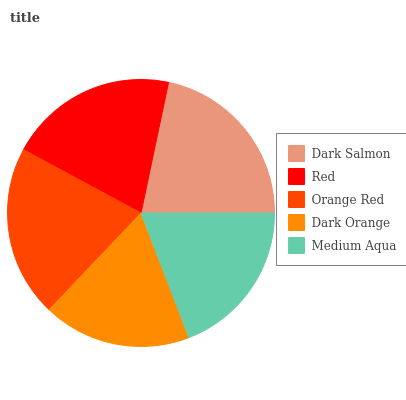Is Dark Orange the minimum?
Answer yes or no. Yes. Is Dark Salmon the maximum?
Answer yes or no. Yes. Is Red the minimum?
Answer yes or no. No. Is Red the maximum?
Answer yes or no. No. Is Dark Salmon greater than Red?
Answer yes or no. Yes. Is Red less than Dark Salmon?
Answer yes or no. Yes. Is Red greater than Dark Salmon?
Answer yes or no. No. Is Dark Salmon less than Red?
Answer yes or no. No. Is Red the high median?
Answer yes or no. Yes. Is Red the low median?
Answer yes or no. Yes. Is Dark Salmon the high median?
Answer yes or no. No. Is Medium Aqua the low median?
Answer yes or no. No. 